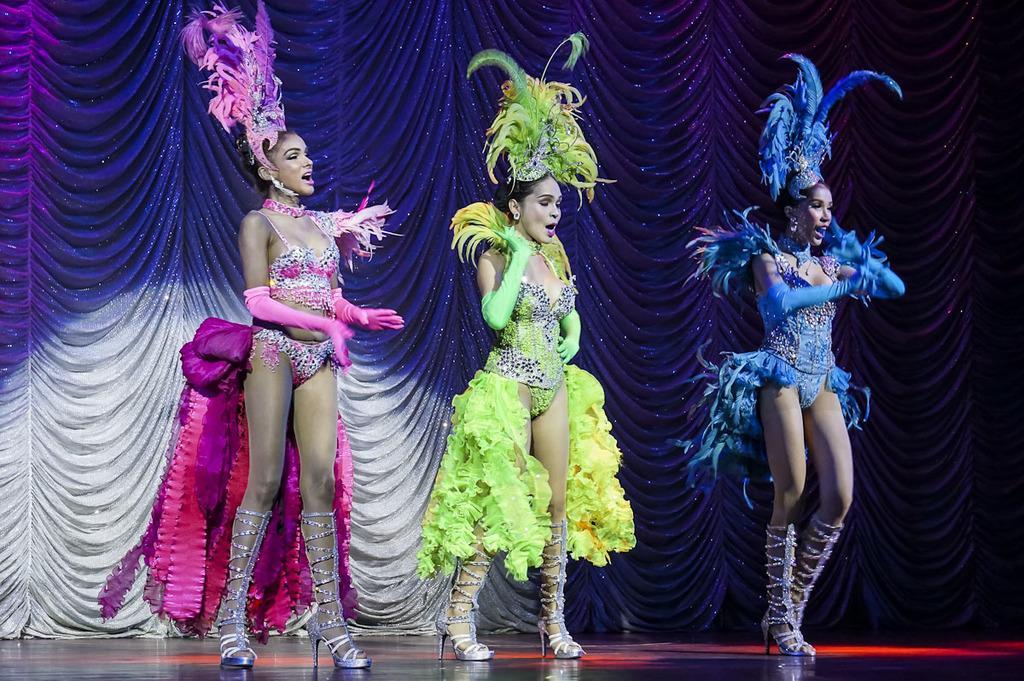Describe this image in one or two sentences. In this image we can see three women are on the stage and they wore fancy dresses. In the background we can see a curtain. 